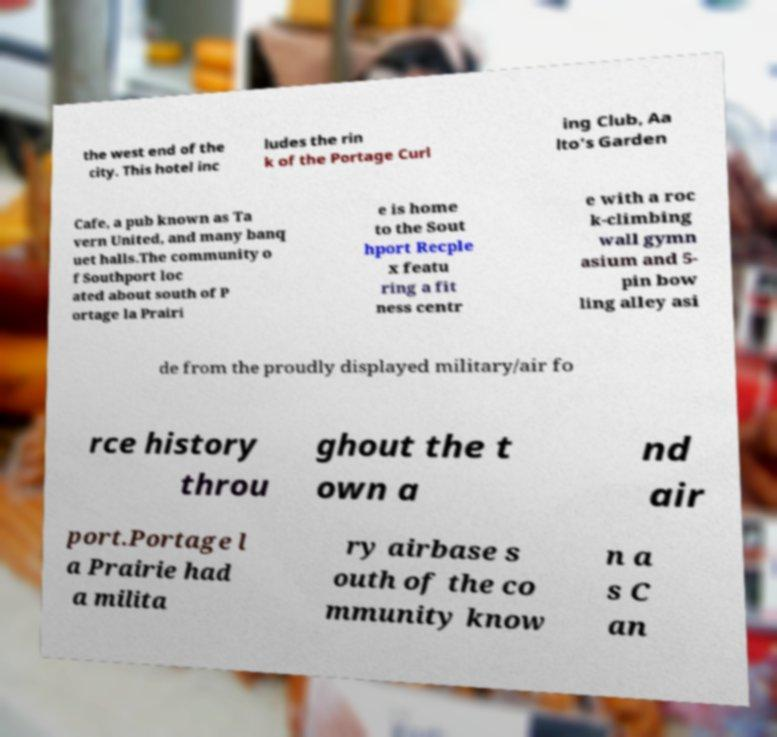Please read and relay the text visible in this image. What does it say? the west end of the city. This hotel inc ludes the rin k of the Portage Curl ing Club, Aa lto's Garden Cafe, a pub known as Ta vern United, and many banq uet halls.The community o f Southport loc ated about south of P ortage la Prairi e is home to the Sout hport Recple x featu ring a fit ness centr e with a roc k-climbing wall gymn asium and 5- pin bow ling alley asi de from the proudly displayed military/air fo rce history throu ghout the t own a nd air port.Portage l a Prairie had a milita ry airbase s outh of the co mmunity know n a s C an 